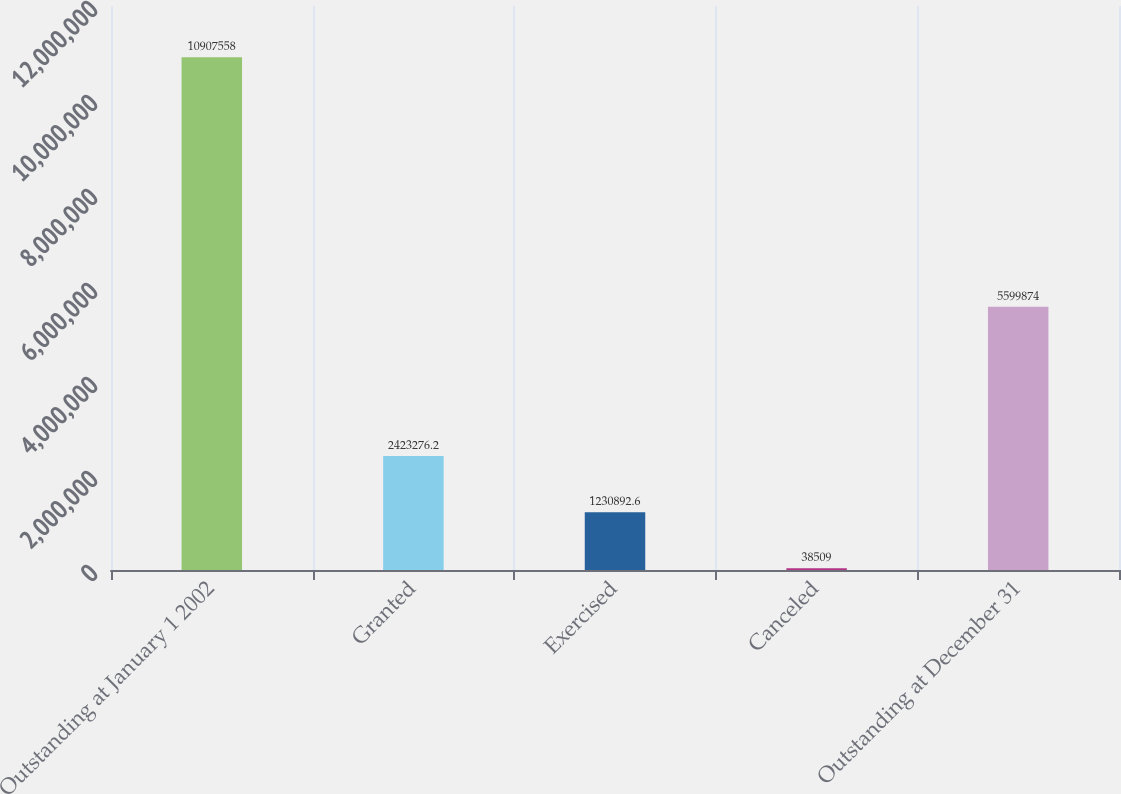<chart> <loc_0><loc_0><loc_500><loc_500><bar_chart><fcel>Outstanding at January 1 2002<fcel>Granted<fcel>Exercised<fcel>Canceled<fcel>Outstanding at December 31<nl><fcel>1.09076e+07<fcel>2.42328e+06<fcel>1.23089e+06<fcel>38509<fcel>5.59987e+06<nl></chart> 